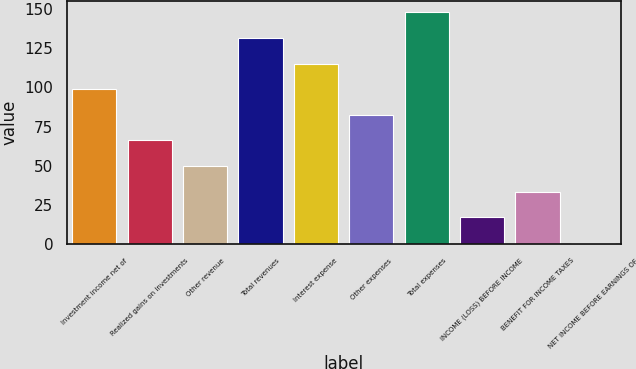Convert chart to OTSL. <chart><loc_0><loc_0><loc_500><loc_500><bar_chart><fcel>Investment income net of<fcel>Realized gains on investments<fcel>Other revenue<fcel>Total revenues<fcel>Interest expense<fcel>Other expenses<fcel>Total expenses<fcel>INCOME (LOSS) BEFORE INCOME<fcel>BENEFIT FOR INCOME TAXES<fcel>NET INCOME BEFORE EARNINGS OF<nl><fcel>98.8<fcel>66.2<fcel>49.9<fcel>131.4<fcel>115.1<fcel>82.5<fcel>147.7<fcel>17.3<fcel>33.6<fcel>1<nl></chart> 